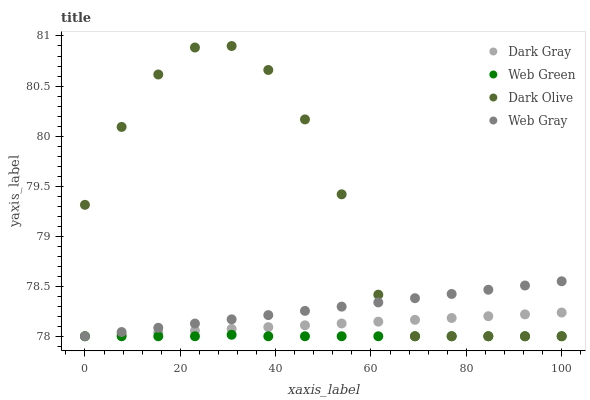Does Web Green have the minimum area under the curve?
Answer yes or no. Yes. Does Dark Olive have the maximum area under the curve?
Answer yes or no. Yes. Does Web Gray have the minimum area under the curve?
Answer yes or no. No. Does Web Gray have the maximum area under the curve?
Answer yes or no. No. Is Web Gray the smoothest?
Answer yes or no. Yes. Is Dark Olive the roughest?
Answer yes or no. Yes. Is Dark Olive the smoothest?
Answer yes or no. No. Is Web Gray the roughest?
Answer yes or no. No. Does Dark Gray have the lowest value?
Answer yes or no. Yes. Does Dark Olive have the highest value?
Answer yes or no. Yes. Does Web Gray have the highest value?
Answer yes or no. No. Does Dark Olive intersect Web Gray?
Answer yes or no. Yes. Is Dark Olive less than Web Gray?
Answer yes or no. No. Is Dark Olive greater than Web Gray?
Answer yes or no. No. 